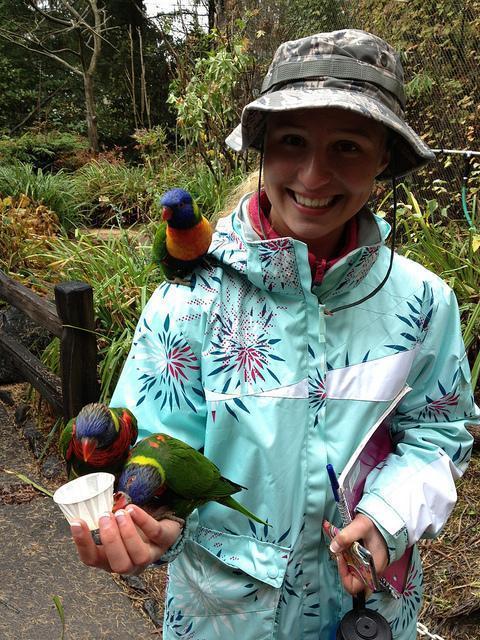How many birds are on the lady?
Give a very brief answer. 3. How many birds are visible?
Give a very brief answer. 2. 